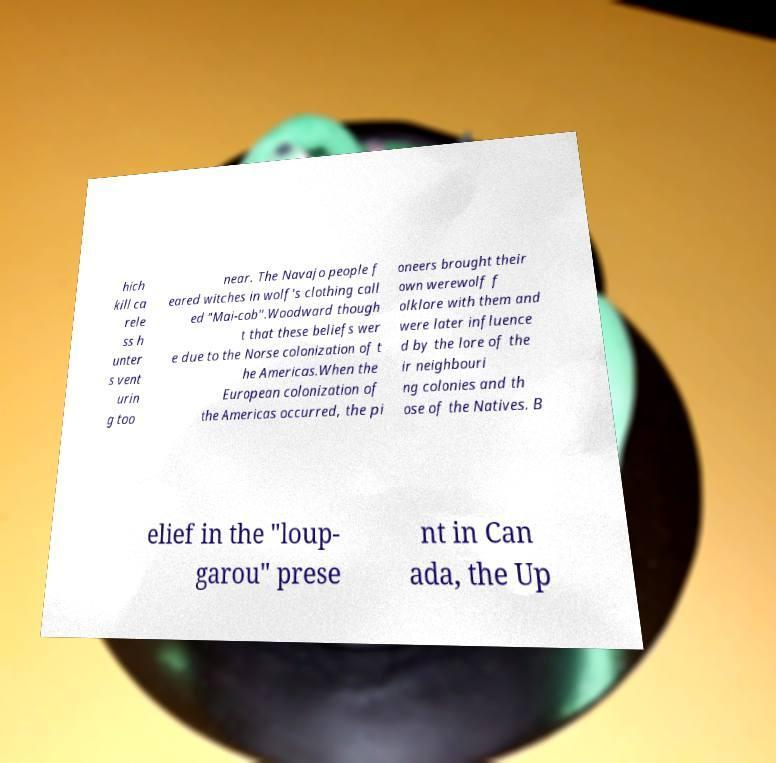Could you assist in decoding the text presented in this image and type it out clearly? hich kill ca rele ss h unter s vent urin g too near. The Navajo people f eared witches in wolf's clothing call ed "Mai-cob".Woodward though t that these beliefs wer e due to the Norse colonization of t he Americas.When the European colonization of the Americas occurred, the pi oneers brought their own werewolf f olklore with them and were later influence d by the lore of the ir neighbouri ng colonies and th ose of the Natives. B elief in the "loup- garou" prese nt in Can ada, the Up 